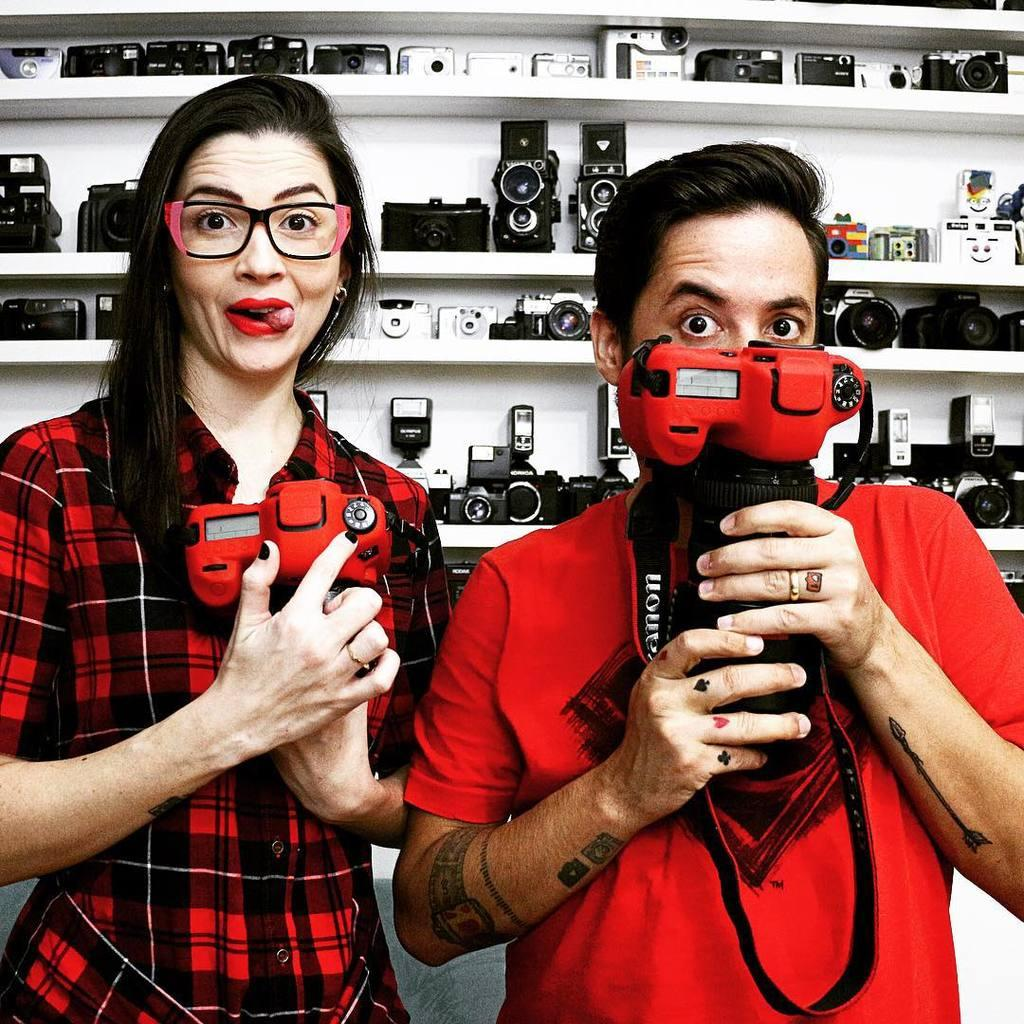How many people are present in the image? There are two people, a man and a woman, present in the image. What are the man and woman holding in the image? The man and woman are both holding cameras. What can be seen in the background of the image? There are cameras in racks in the background of the image. What type of punishment is being administered to the plant in the image? There is no plant present in the image, and therefore no punishment is being administered. What type of polish is being applied to the cameras in the image? There is no indication in the image that any polish is being applied to the cameras. 